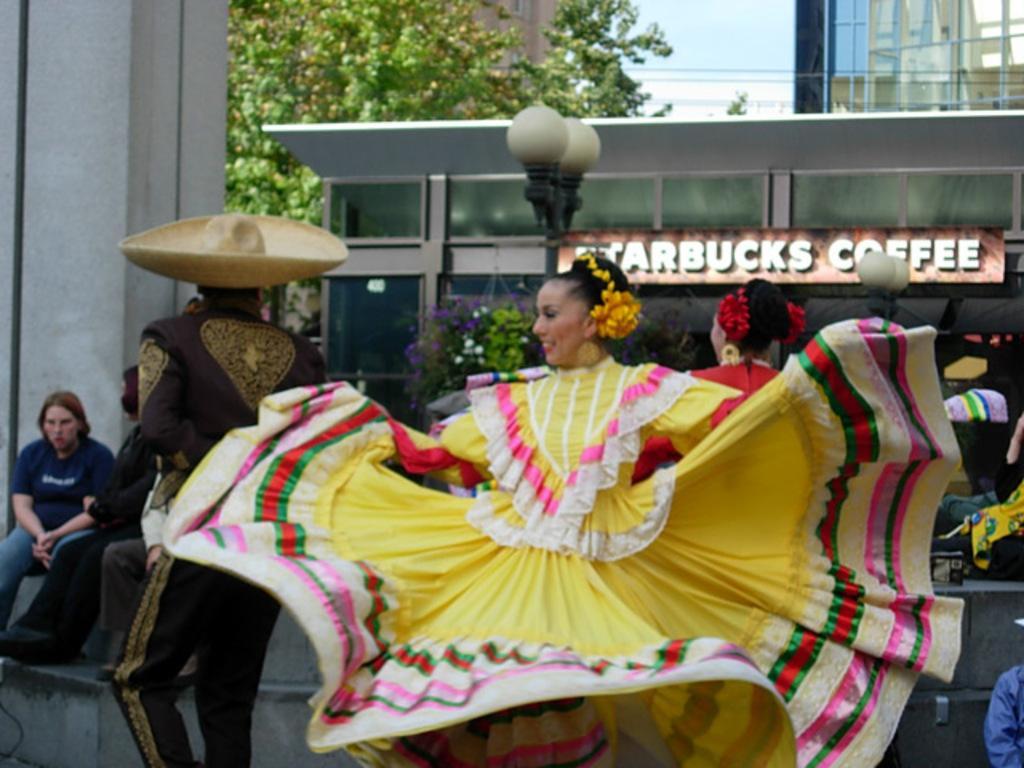Please provide a concise description of this image. In this image I see number of people in which few people are wearing costumes which are colorful. In the background I see buildings and I see a board over here on which there are words written and I see the light poles and I see the sky, wires and I see green leaves on the stems. 